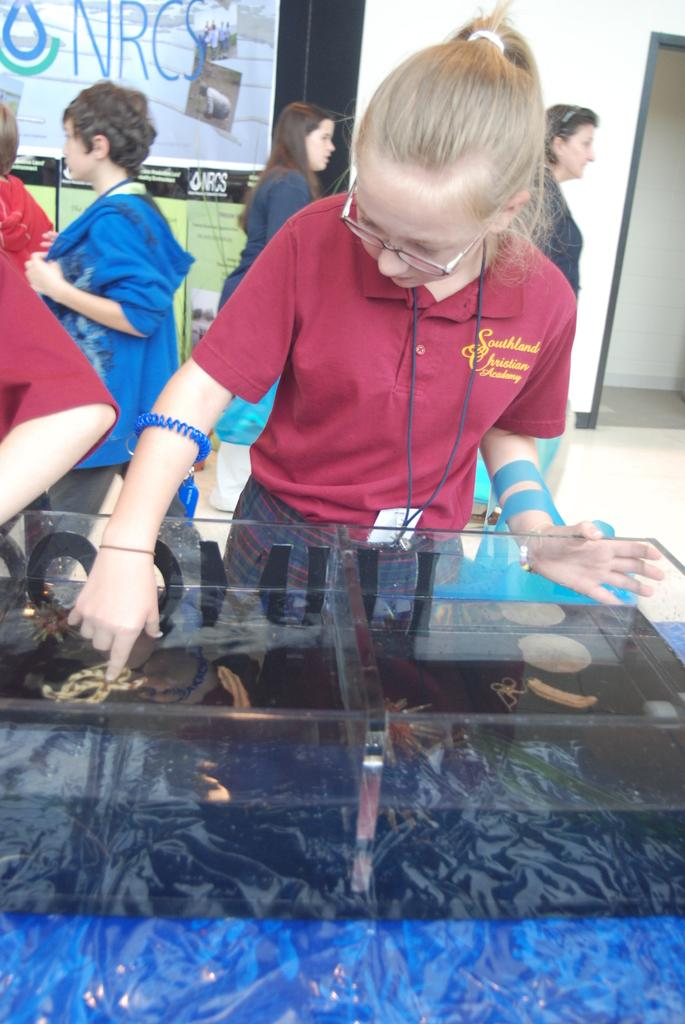Who or what can be seen in the image? There are people in the image. What else is present in the image besides people? There are banners and a wall in the image. Can you describe the aquarium in the image? The image contains an aquarium, which has fishes and water inside it. What is the purpose of the banners in the image? The purpose of the banners in the image cannot be determined from the provided facts. What type of bird can be seen flying near the edge of the wall in the image? There is no bird present in the image; it only features people, banners, a wall, and an aquarium. 